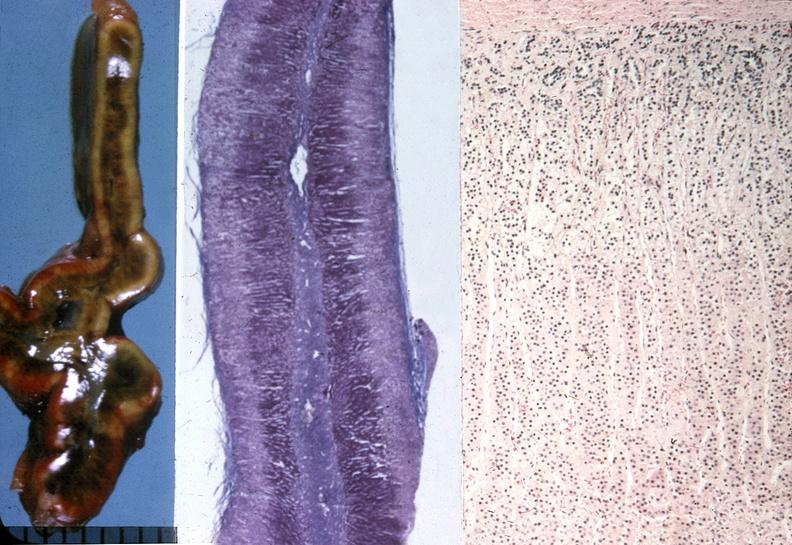does this image show adrenal, cushing syndrome?
Answer the question using a single word or phrase. Yes 